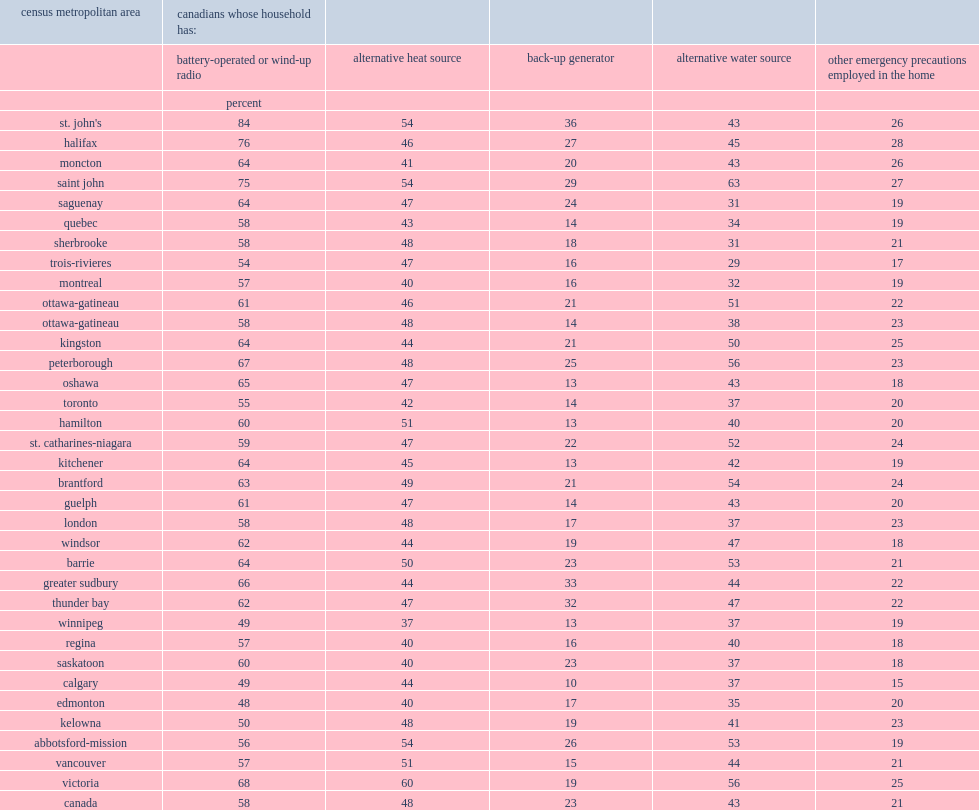In the cmas of st. john's individuals had a wind-up or battery operated radio in their home, what is the percentage of it? 84.0. In the cmas of halifax's individuals had a wind-up or battery operated radio in their home, what is the percentage of it? 76.0. In the cmas of saint john's individuals had a wind-up or battery operated radio in their home, what is the percentage of it? 75.0. In the cmas of edmonton's individuals had a wind-up or battery operated radio in their home, what is the percentage of it? 48.0. In the cmas of calgary's individuals had a wind-up or battery operated radio in their home, what is the percentage of it? 49.0. In the cmas of winnipeg's individuals had a wind-up or battery operated radio in their home, what is the percentage of it? 49.0. What is the percentage of supplementary water supplies among individuals in saint john in 2014? 63.0. What is the percentage of supplementary water supplies among individuals in peterborough in 2014? 56.0. What is the percentage of supplementary water supplies among individuals in victoria in 2014? 56.0. In addition, having an alternate source of heat was most frequently reported in victoria in 2014, what is the percentage of it? 60.0. In addition, having an alternate source of heat was most frequently reported in winnipeg in 2014, what is the percentage of it? 37.0. Individuals from st. john's had the largest proportion of individuals with back-up generators in their homes in 2014, what is the percentage ? 36.0. Individuals from calgary had the largest proportion of individuals with back-up generators in their homes in 2014, what is the percentage ? 10.0. 